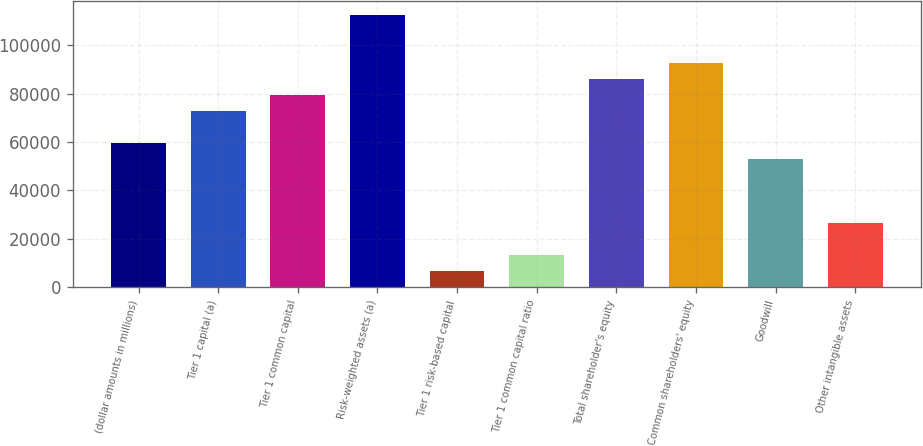<chart> <loc_0><loc_0><loc_500><loc_500><bar_chart><fcel>(dollar amounts in millions)<fcel>Tier 1 capital (a)<fcel>Tier 1 common capital<fcel>Risk-weighted assets (a)<fcel>Tier 1 risk-based capital<fcel>Tier 1 common capital ratio<fcel>Total shareholder's equity<fcel>Common shareholders' equity<fcel>Goodwill<fcel>Other intangible assets<nl><fcel>59570.2<fcel>72805.8<fcel>79423.7<fcel>112513<fcel>6627.54<fcel>13245.4<fcel>86041.5<fcel>92659.3<fcel>52952.3<fcel>26481<nl></chart> 